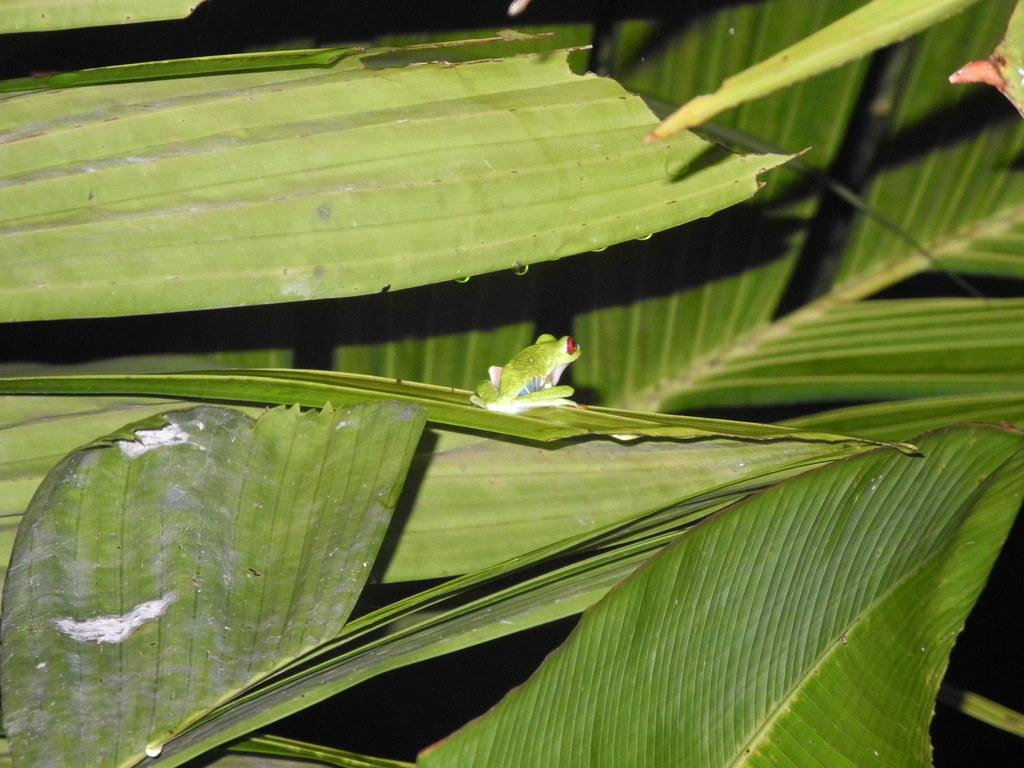What is the main subject in the center of the image? There is a frog in the center of the image. What is the frog sitting on? The frog is on a leaf. What type of vegetation can be seen in the image? There are leaves around the area of the image. What is the purpose of the carpenter in the image? There is no carpenter present in the image. 